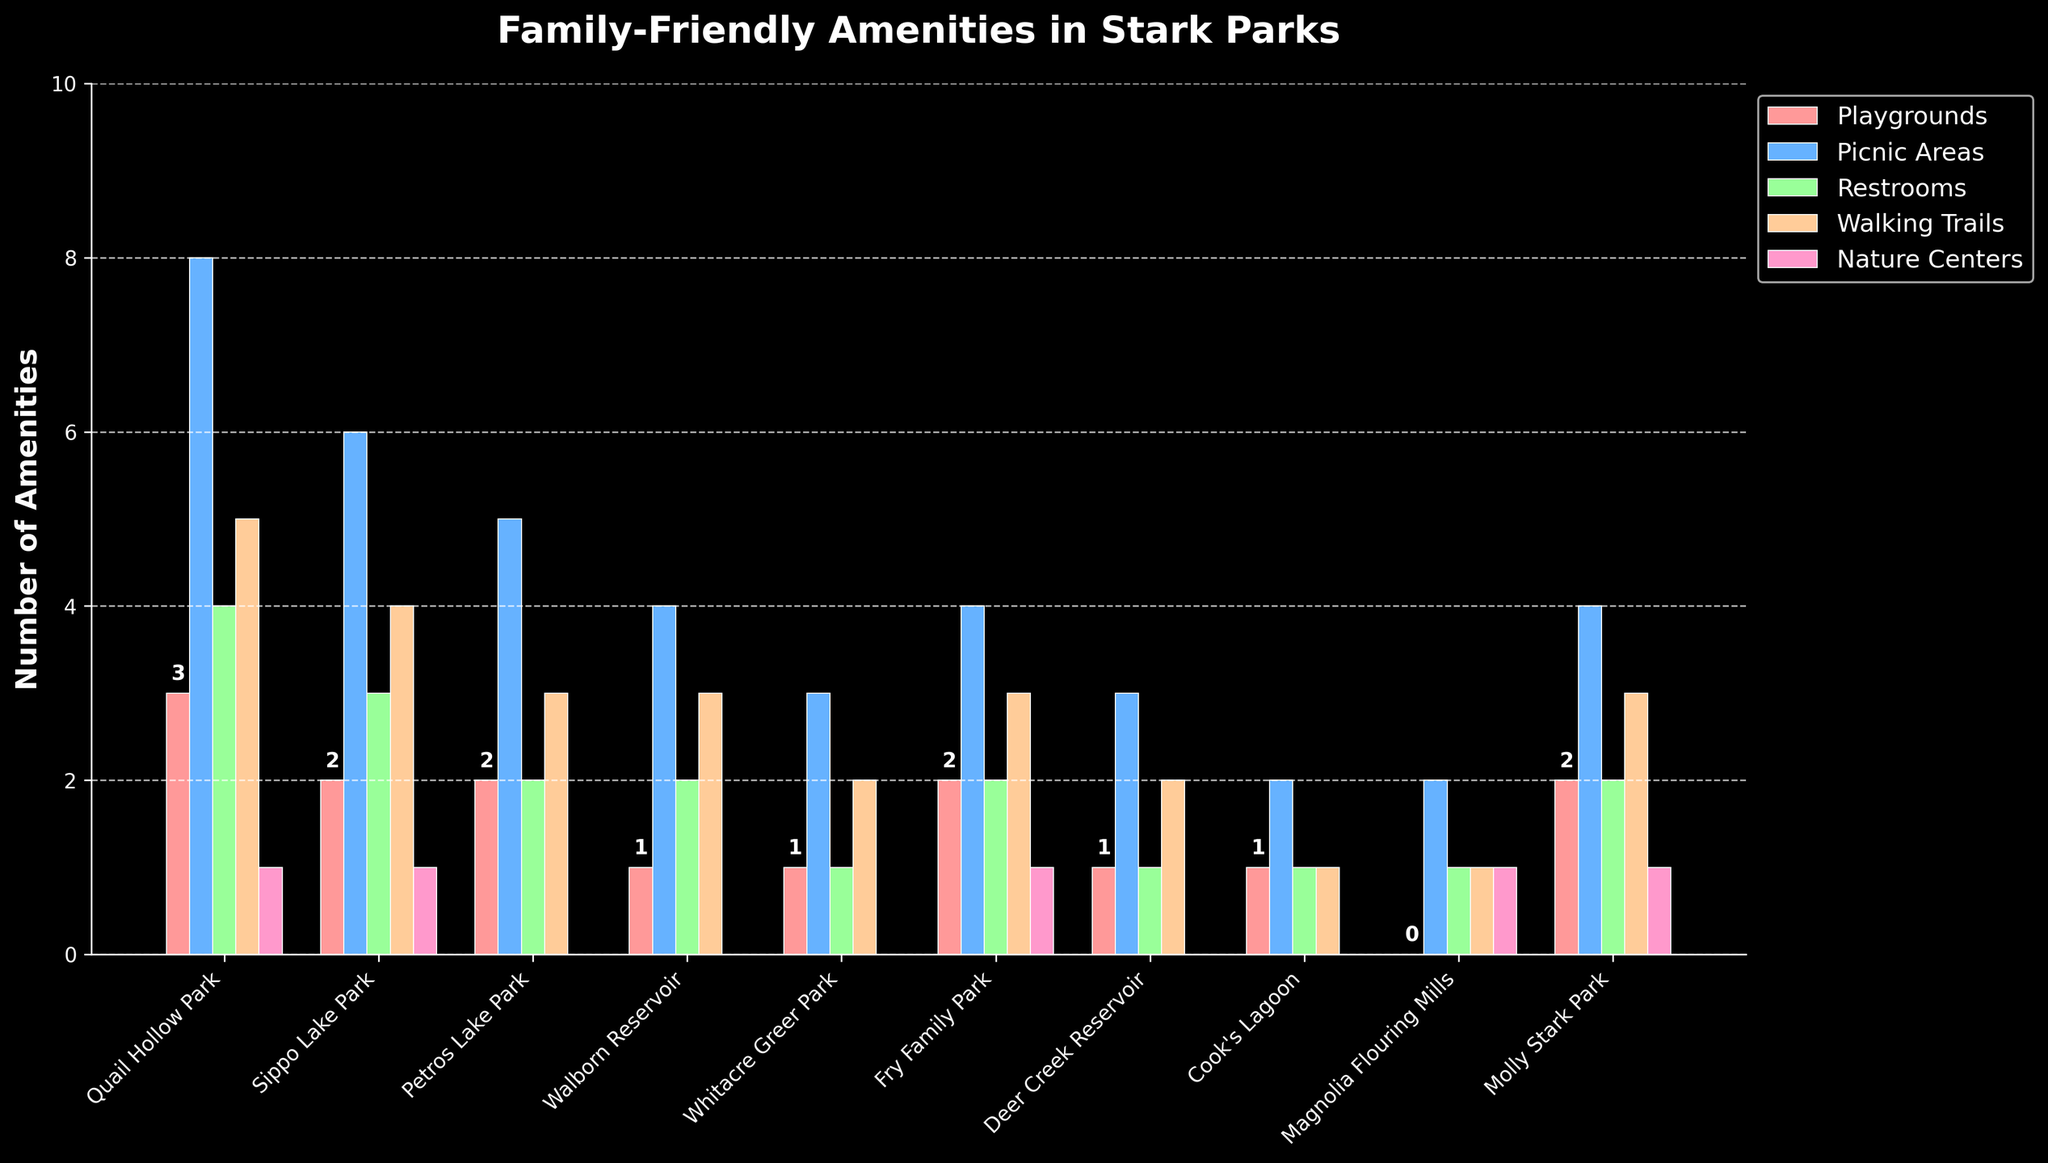Which park has the most picnic areas? To find which park has the most picnic areas, look at the heights of the bars corresponding to picnic areas. The highest bar represents the park with the most picnic areas.
Answer: Quail Hollow Park Which parks have only one playground? Locate the bars corresponding to playgrounds and look for the bars with a height of 1. The parks with bars at this height have only one playground.
Answer: Walborn Reservoir, Whitacre Greer Park, Deer Creek Reservoir, Cook's Lagoon Which amenity has the highest count in Sippo Lake Park? Look at the different colored bars for Sippo Lake Park and identify the tallest bar, which represents the highest count.
Answer: Picnic Areas What is the total number of restrooms across all parks? Add the heights of all the bars corresponding to restrooms from each park. The sum is the total number of restrooms.
Answer: 19 Which park has the lowest number of amenities in total? To find the park with the lowest total number of amenities, add the heights of all the bars for each park and compare the totals.
Answer: Cook's Lagoon How many parks have nature centers? Look at the bars corresponding to nature centers, count the number of parks that have a bar greater than zero.
Answer: 5 Which park has the same number of playgrounds and walking trails? Compare the heights of the bars for playgrounds and walking trails for each park, and find the park where the heights are equal.
Answer: Quail Hollow Park How many total playgrounds are in all parks combined? Sum the heights of all the bars corresponding to playgrounds from each park.
Answer: 15 Which park has the second highest number of total amenities? Calculate the total number of amenities for each park by summing the bar heights, then find the park with the second highest total.
Answer: Sippo Lake Park What is the average number of picnic areas per park? Sum the heights of all the bars corresponding to picnic areas and divide by the number of parks (10).
Answer: 4 